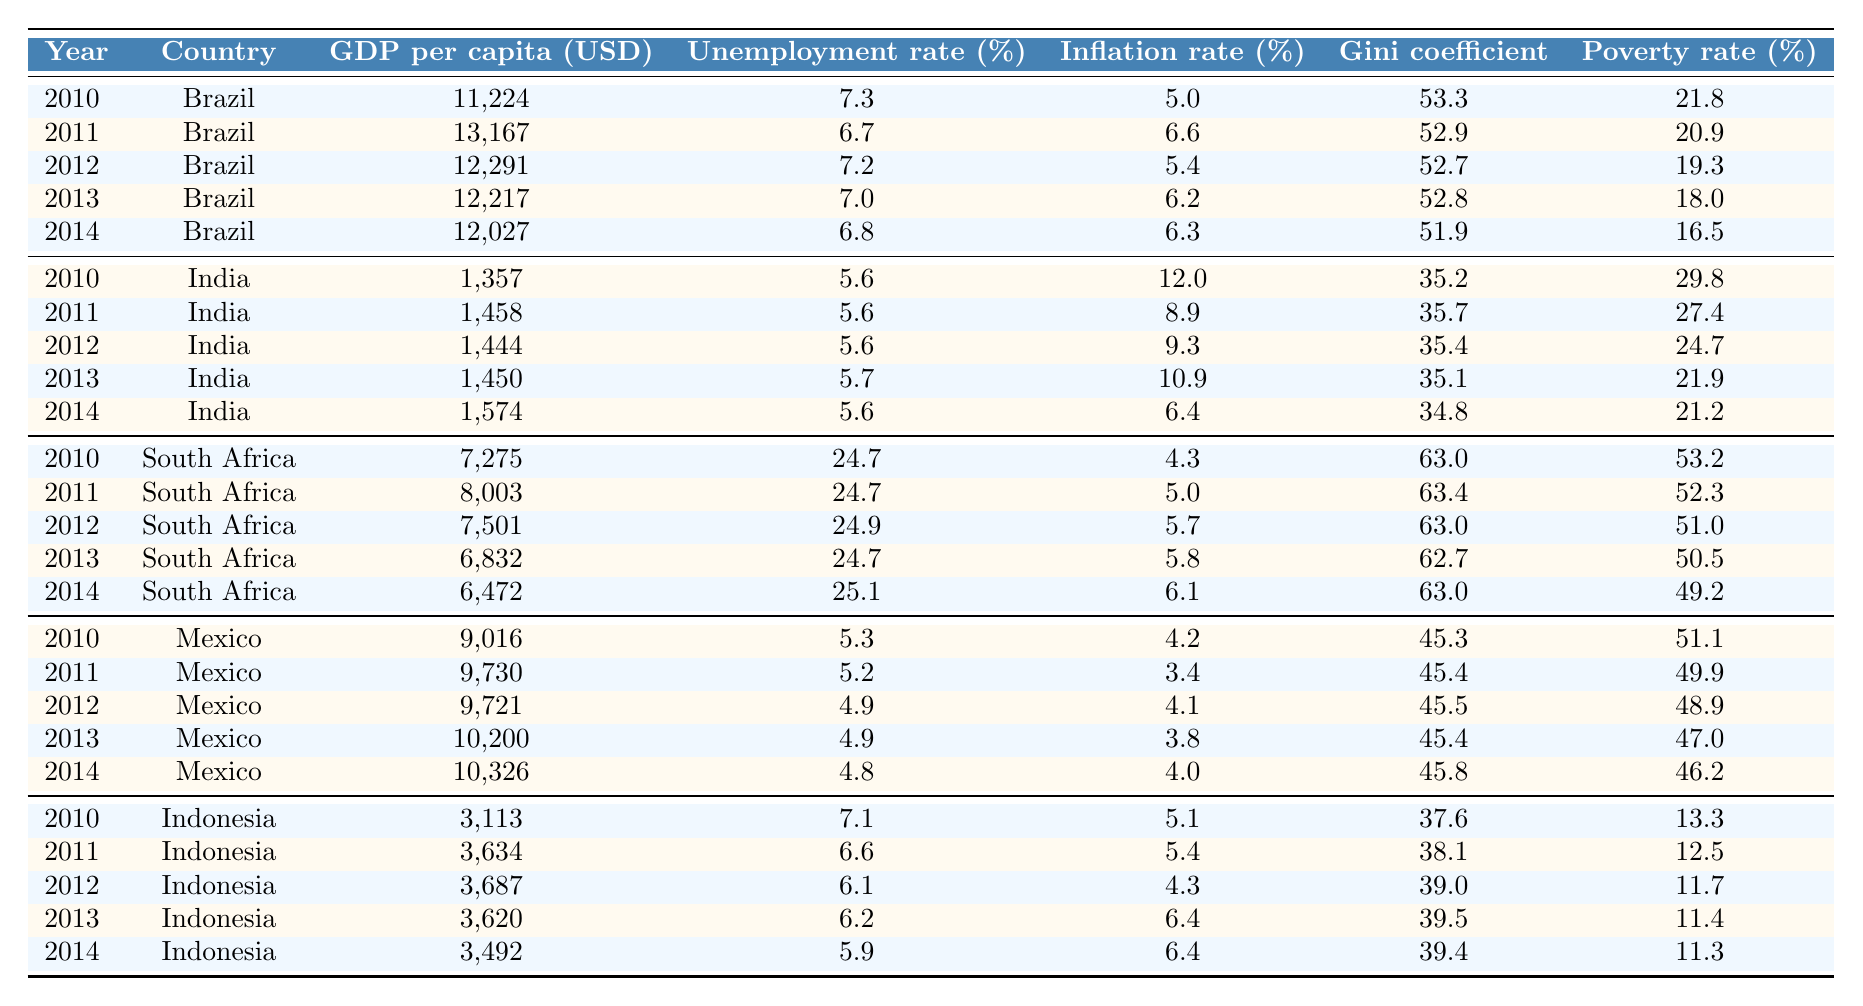What is the GDP per capita of Brazil in 2014? The table shows that in 2014, Brazil had a GDP per capita of 12,027 USD.
Answer: 12,027 USD What was the highest unemployment rate recorded for any country in 2010? The table indicates that South Africa had the highest unemployment rate in 2010 at 24.7%.
Answer: 24.7% Which country had the lowest poverty rate in 2012? In 2012, Indonesia had the lowest poverty rate at 11.7%.
Answer: 11.7% What is the inflation rate of India in 2013? According to the table, India had an inflation rate of 10.9% in 2013.
Answer: 10.9% Did Mexico's GDP per capita increase from 2010 to 2014? By comparing the values, Mexico's GDP per capita increased from 9,016 USD in 2010 to 10,326 USD in 2014, confirming an increase.
Answer: Yes Which country showed the most significant reduction in poverty rate between 2010 and 2014? For Brazil, the poverty rate decreased from 21.8% in 2010 to 16.5% in 2014, a drop of 5.3 percentage points, while other countries had smaller reductions.
Answer: Brazil What was the average Gini coefficient for Brazil from 2010 to 2014? The Gini coefficients for Brazil from 2010 to 2014 were 53.3, 52.9, 52.7, 52.8, and 51.9. Adding these up gives 263.6, and dividing by 5 gives an average Gini coefficient of 52.72.
Answer: 52.72 Was the Gini coefficient for South Africa consistent from 2010 to 2014? The Gini coefficients for South Africa varied between 63.0 and 62.7 during these years, indicating inconsistency.
Answer: No What trend can be observed in Brazil's poverty rate from 2010 to 2014? Analyzing the table shows that Brazil's poverty rate consistently decreased each year, from 21.8% in 2010 to 16.5% in 2014.
Answer: Decreasing trend Which country had the worst Gini coefficient in 2011? South Africa had the worst Gini coefficient in 2011 at 63.4, as indicated in the table.
Answer: 63.4 How did the unemployment rate in Indonesia change from 2010 to 2014? The unemployment rate in Indonesia decreased from 7.1% in 2010 to 5.9% in 2014, indicating a downward trend.
Answer: Decreased 